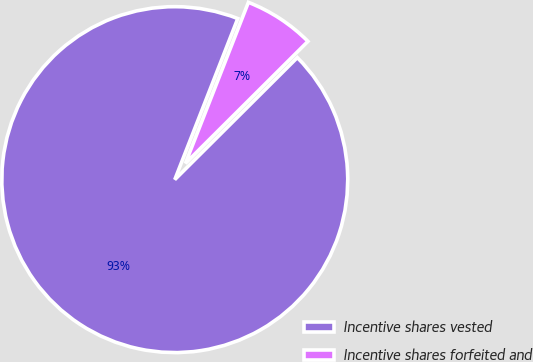Convert chart to OTSL. <chart><loc_0><loc_0><loc_500><loc_500><pie_chart><fcel>Incentive shares vested<fcel>Incentive shares forfeited and<nl><fcel>93.4%<fcel>6.6%<nl></chart> 